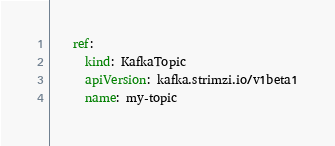<code> <loc_0><loc_0><loc_500><loc_500><_YAML_>    ref:
      kind: KafkaTopic
      apiVersion: kafka.strimzi.io/v1beta1
      name: my-topic
</code> 